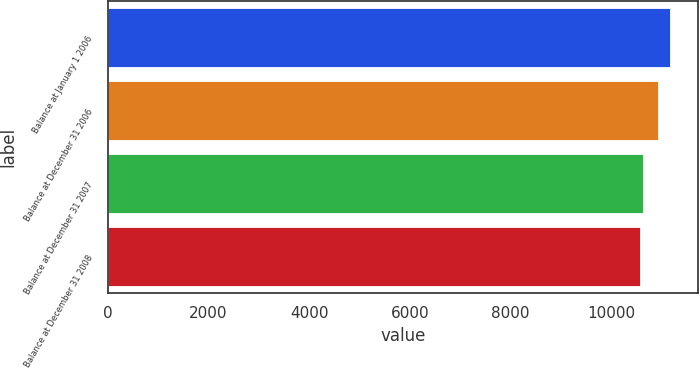<chart> <loc_0><loc_0><loc_500><loc_500><bar_chart><fcel>Balance at January 1 2006<fcel>Balance at December 31 2006<fcel>Balance at December 31 2007<fcel>Balance at December 31 2008<nl><fcel>11168<fcel>10927<fcel>10626.2<fcel>10566<nl></chart> 